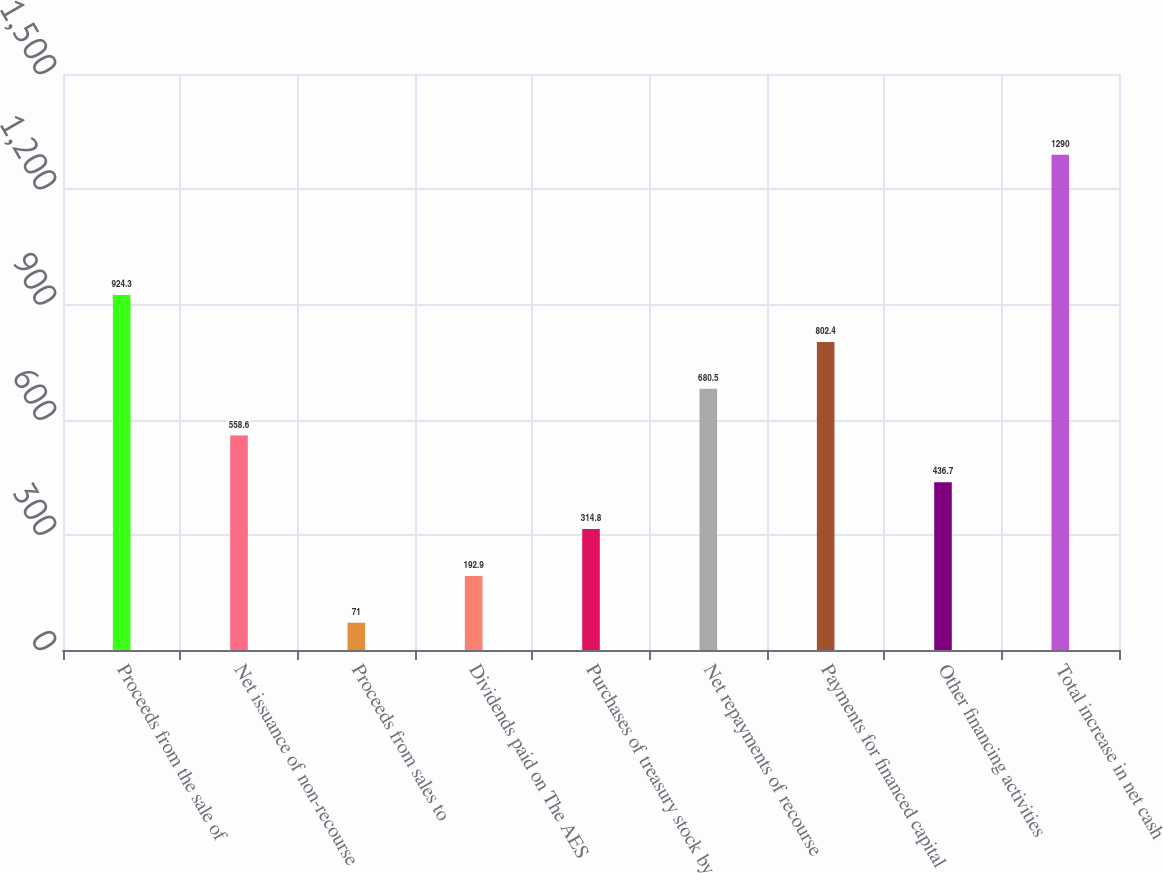<chart> <loc_0><loc_0><loc_500><loc_500><bar_chart><fcel>Proceeds from the sale of<fcel>Net issuance of non-recourse<fcel>Proceeds from sales to<fcel>Dividends paid on The AES<fcel>Purchases of treasury stock by<fcel>Net repayments of recourse<fcel>Payments for financed capital<fcel>Other financing activities<fcel>Total increase in net cash<nl><fcel>924.3<fcel>558.6<fcel>71<fcel>192.9<fcel>314.8<fcel>680.5<fcel>802.4<fcel>436.7<fcel>1290<nl></chart> 